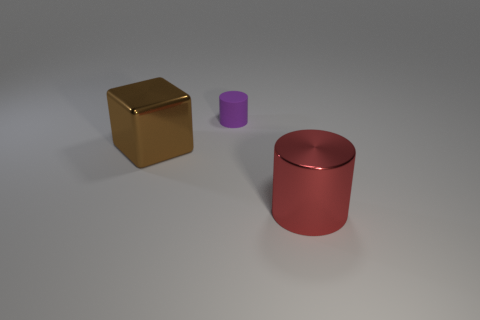Is the size of the cube the same as the red metallic object?
Keep it short and to the point. Yes. The purple matte object is what size?
Give a very brief answer. Small. Are there more brown metallic things than large blue shiny things?
Make the answer very short. Yes. There is a big metal thing behind the large shiny object on the right side of the cylinder that is behind the large red metal cylinder; what is its color?
Provide a succinct answer. Brown. There is a large thing to the right of the large brown cube; is its shape the same as the purple thing?
Offer a very short reply. Yes. There is a thing that is the same size as the metallic cube; what is its color?
Provide a short and direct response. Red. How many tiny cyan things are there?
Offer a terse response. 0. Are the cylinder right of the small purple cylinder and the large block made of the same material?
Offer a very short reply. Yes. What material is the thing that is both right of the big brown metallic thing and in front of the tiny matte cylinder?
Keep it short and to the point. Metal. What is the material of the object on the right side of the cylinder behind the big red thing?
Your answer should be compact. Metal. 